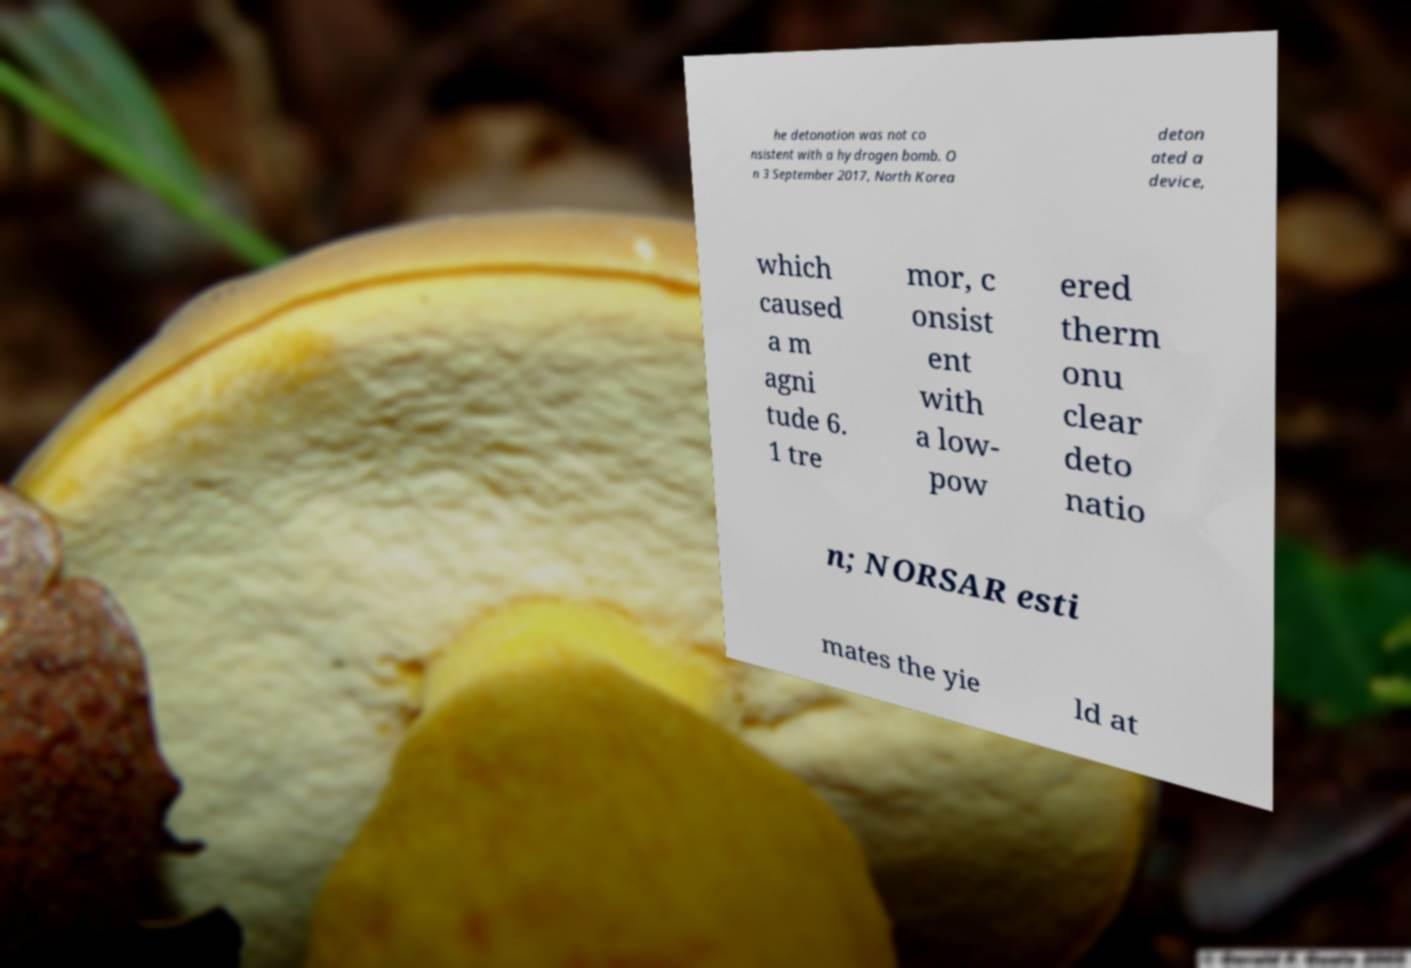For documentation purposes, I need the text within this image transcribed. Could you provide that? he detonation was not co nsistent with a hydrogen bomb. O n 3 September 2017, North Korea deton ated a device, which caused a m agni tude 6. 1 tre mor, c onsist ent with a low- pow ered therm onu clear deto natio n; NORSAR esti mates the yie ld at 